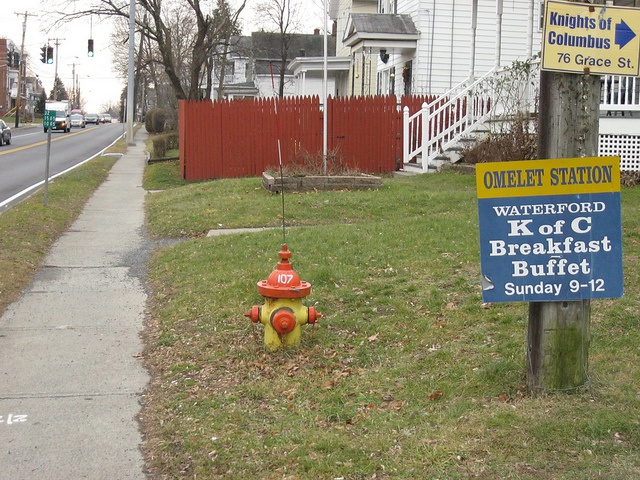Describe the objects in this image and their specific colors. I can see fire hydrant in white, brown, olive, and salmon tones, truck in white, darkgray, black, and gray tones, car in white, gray, darkgray, black, and lightgray tones, traffic light in white, gray, darkgray, and black tones, and car in white, darkgray, lightgray, and gray tones in this image. 